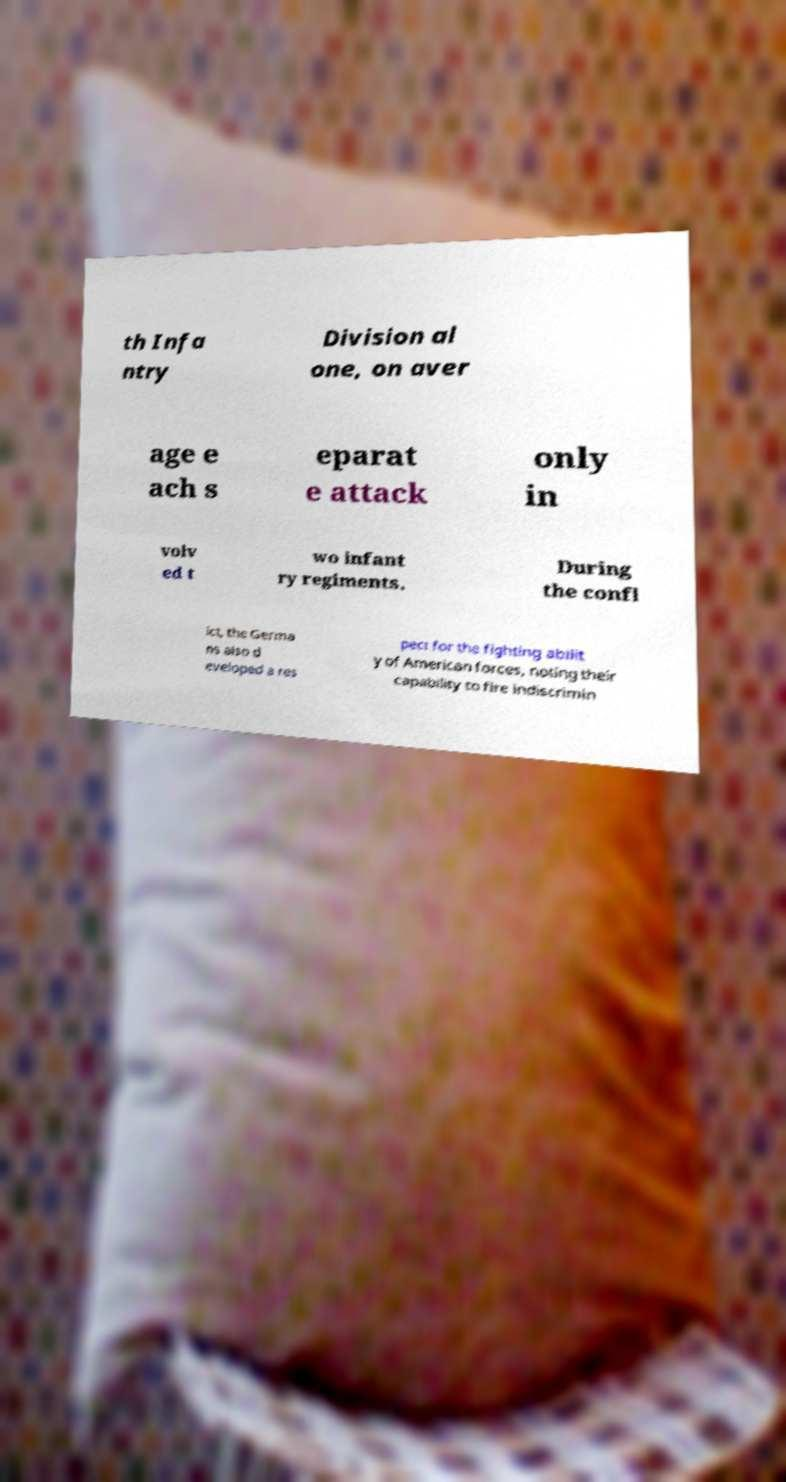Could you extract and type out the text from this image? th Infa ntry Division al one, on aver age e ach s eparat e attack only in volv ed t wo infant ry regiments. During the confl ict, the Germa ns also d eveloped a res pect for the fighting abilit y of American forces, noting their capability to fire indiscrimin 